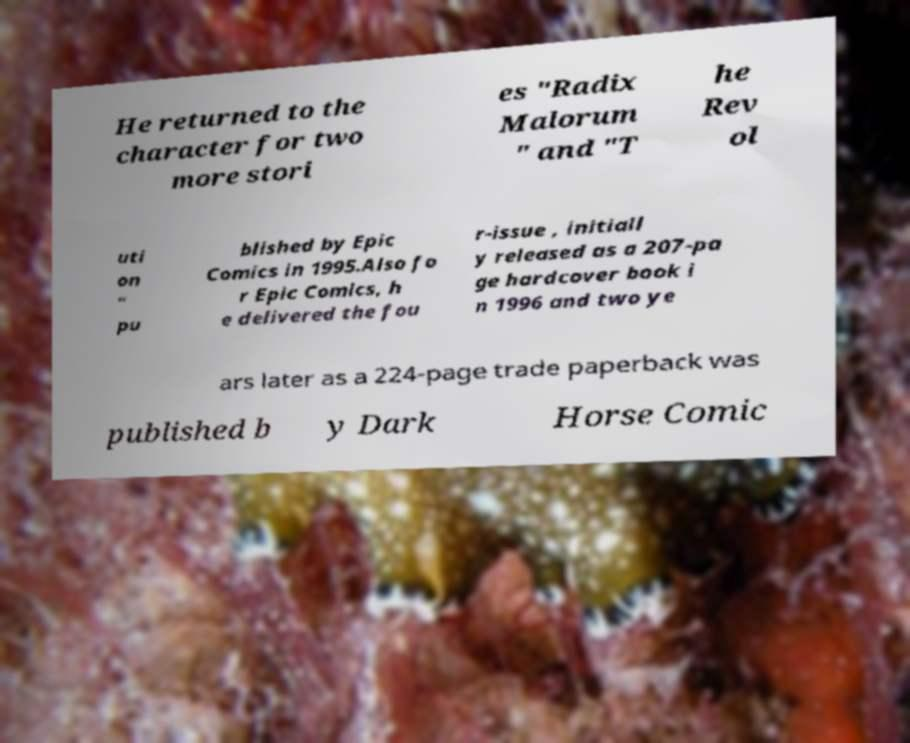What messages or text are displayed in this image? I need them in a readable, typed format. He returned to the character for two more stori es "Radix Malorum " and "T he Rev ol uti on " pu blished by Epic Comics in 1995.Also fo r Epic Comics, h e delivered the fou r-issue , initiall y released as a 207-pa ge hardcover book i n 1996 and two ye ars later as a 224-page trade paperback was published b y Dark Horse Comic 